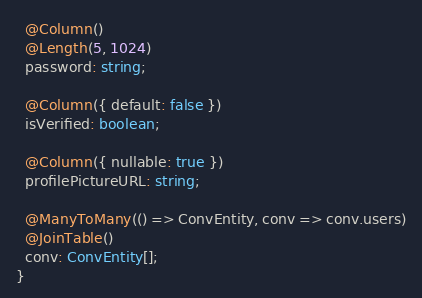Convert code to text. <code><loc_0><loc_0><loc_500><loc_500><_TypeScript_>  @Column()
  @Length(5, 1024)
  password: string;

  @Column({ default: false })
  isVerified: boolean;

  @Column({ nullable: true })
  profilePictureURL: string;

  @ManyToMany(() => ConvEntity, conv => conv.users)
  @JoinTable()
  conv: ConvEntity[];
}
</code> 